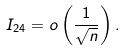Convert formula to latex. <formula><loc_0><loc_0><loc_500><loc_500>I _ { 2 4 } = o \left ( \frac { 1 } { \sqrt { n } } \right ) .</formula> 